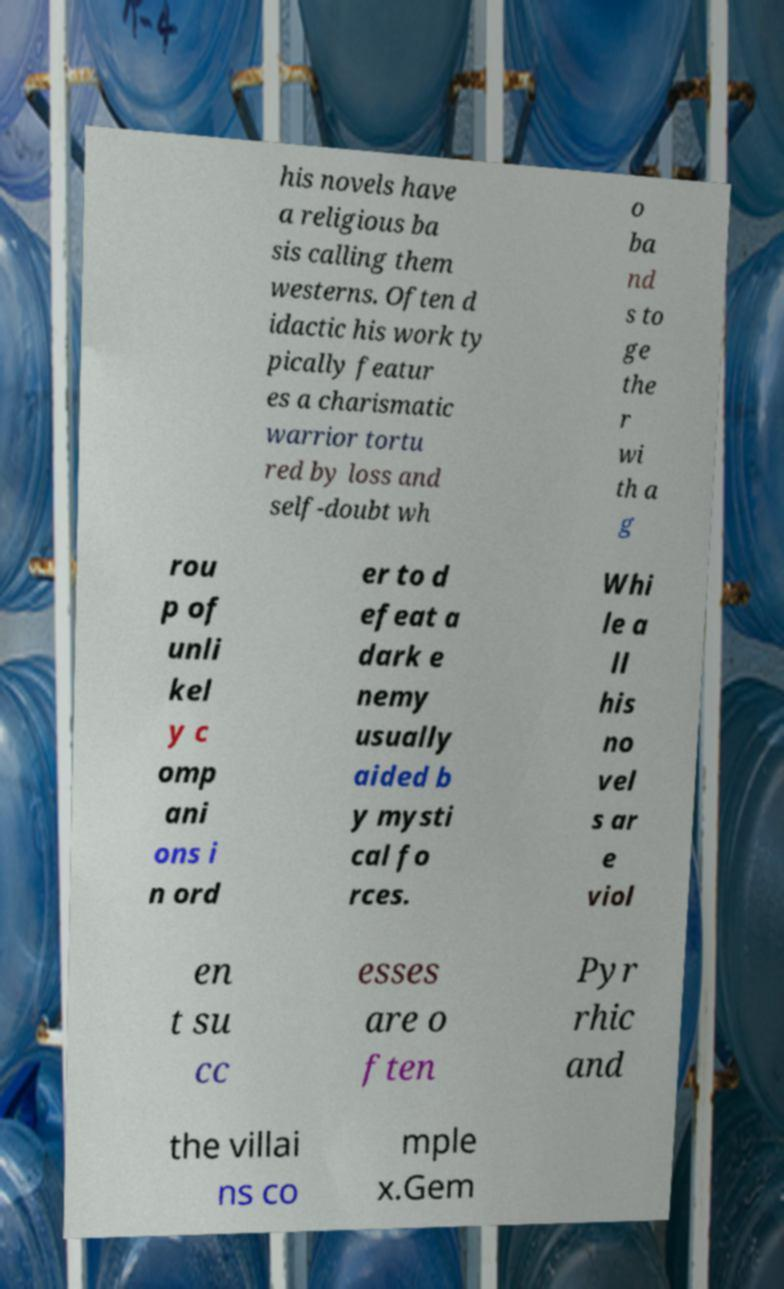Could you extract and type out the text from this image? his novels have a religious ba sis calling them westerns. Often d idactic his work ty pically featur es a charismatic warrior tortu red by loss and self-doubt wh o ba nd s to ge the r wi th a g rou p of unli kel y c omp ani ons i n ord er to d efeat a dark e nemy usually aided b y mysti cal fo rces. Whi le a ll his no vel s ar e viol en t su cc esses are o ften Pyr rhic and the villai ns co mple x.Gem 